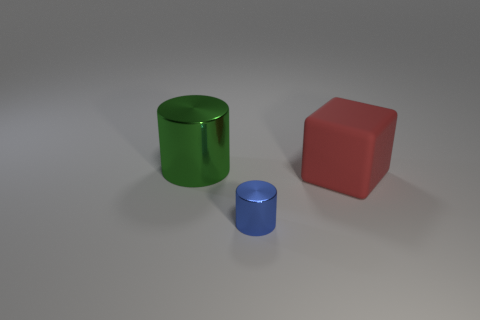Do the block and the green cylinder have the same material?
Offer a terse response. No. There is a blue thing that is the same material as the green cylinder; what is its shape?
Keep it short and to the point. Cylinder. What number of rubber objects are on the left side of the shiny thing that is in front of the big green metal object?
Provide a succinct answer. 0. How many big things are right of the small object and to the left of the large cube?
Provide a succinct answer. 0. How many other objects are the same material as the small thing?
Give a very brief answer. 1. There is a shiny cylinder behind the metal cylinder in front of the green object; what color is it?
Provide a short and direct response. Green. Does the green cylinder have the same size as the rubber thing?
Ensure brevity in your answer.  Yes. There is a red thing that is the same size as the green cylinder; what shape is it?
Provide a succinct answer. Cube. Do the metal cylinder that is behind the rubber block and the large matte cube have the same size?
Offer a terse response. Yes. There is a red cube that is the same size as the green cylinder; what is it made of?
Provide a succinct answer. Rubber. 